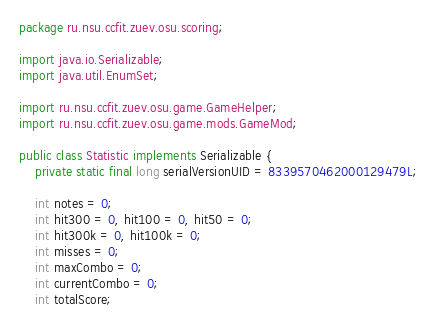Convert code to text. <code><loc_0><loc_0><loc_500><loc_500><_Java_>package ru.nsu.ccfit.zuev.osu.scoring;

import java.io.Serializable;
import java.util.EnumSet;

import ru.nsu.ccfit.zuev.osu.game.GameHelper;
import ru.nsu.ccfit.zuev.osu.game.mods.GameMod;

public class Statistic implements Serializable {
    private static final long serialVersionUID = 8339570462000129479L;

    int notes = 0;
    int hit300 = 0, hit100 = 0, hit50 = 0;
    int hit300k = 0, hit100k = 0;
    int misses = 0;
    int maxCombo = 0;
    int currentCombo = 0;
    int totalScore;</code> 